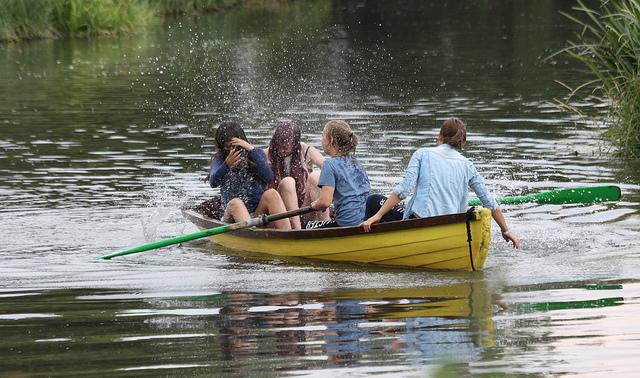What is the green item?

Choices:
A) frog
B) antelope
C) lizard
D) oar oar 